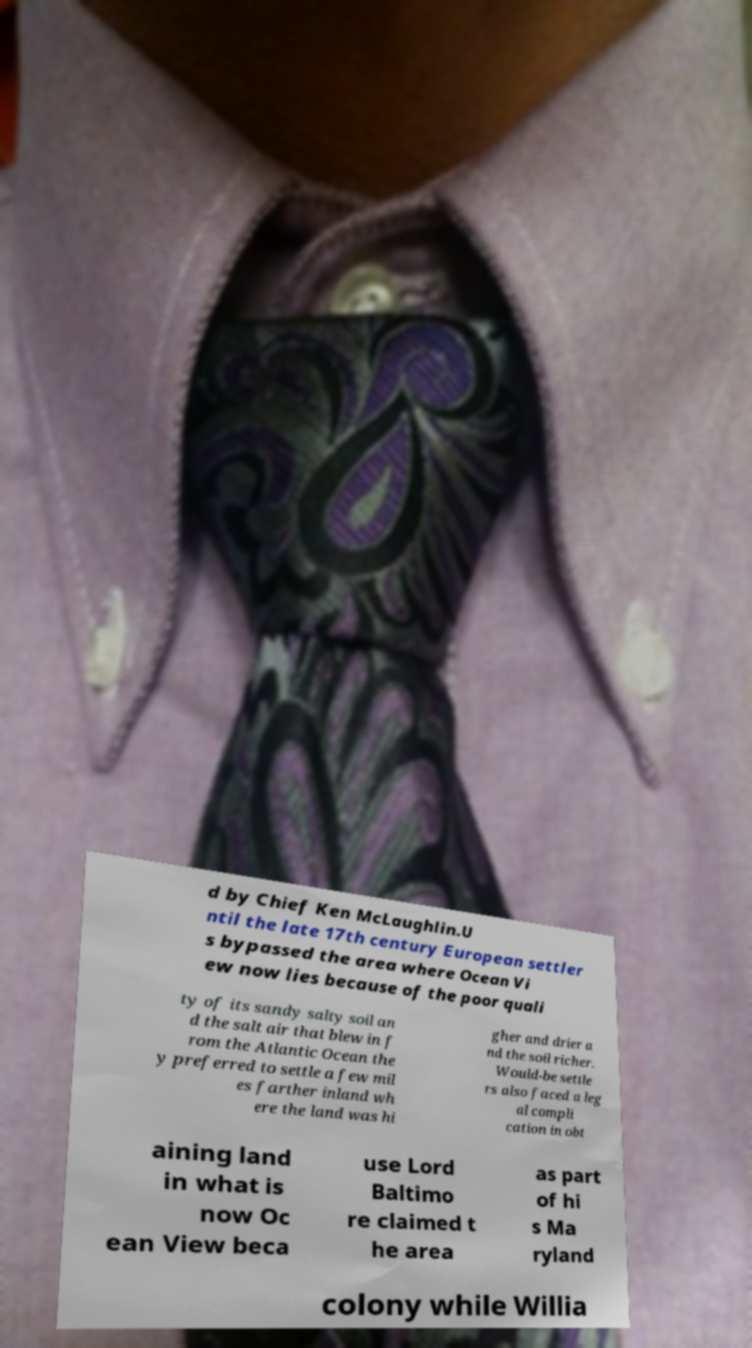Can you read and provide the text displayed in the image?This photo seems to have some interesting text. Can you extract and type it out for me? d by Chief Ken McLaughlin.U ntil the late 17th century European settler s bypassed the area where Ocean Vi ew now lies because of the poor quali ty of its sandy salty soil an d the salt air that blew in f rom the Atlantic Ocean the y preferred to settle a few mil es farther inland wh ere the land was hi gher and drier a nd the soil richer. Would-be settle rs also faced a leg al compli cation in obt aining land in what is now Oc ean View beca use Lord Baltimo re claimed t he area as part of hi s Ma ryland colony while Willia 